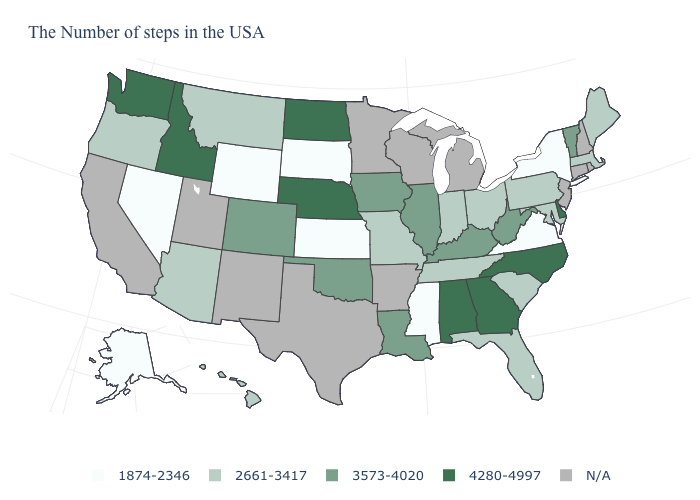What is the value of Nebraska?
Quick response, please. 4280-4997. Which states hav the highest value in the West?
Give a very brief answer. Idaho, Washington. What is the value of Vermont?
Answer briefly. 3573-4020. Name the states that have a value in the range 4280-4997?
Give a very brief answer. Delaware, North Carolina, Georgia, Alabama, Nebraska, North Dakota, Idaho, Washington. Name the states that have a value in the range 4280-4997?
Keep it brief. Delaware, North Carolina, Georgia, Alabama, Nebraska, North Dakota, Idaho, Washington. What is the lowest value in states that border Missouri?
Answer briefly. 1874-2346. What is the lowest value in the South?
Write a very short answer. 1874-2346. Does the map have missing data?
Be succinct. Yes. What is the value of Alabama?
Write a very short answer. 4280-4997. Name the states that have a value in the range 1874-2346?
Write a very short answer. New York, Virginia, Mississippi, Kansas, South Dakota, Wyoming, Nevada, Alaska. What is the lowest value in states that border Wyoming?
Write a very short answer. 1874-2346. What is the lowest value in states that border Washington?
Answer briefly. 2661-3417. Among the states that border Iowa , which have the highest value?
Short answer required. Nebraska. Which states have the lowest value in the MidWest?
Be succinct. Kansas, South Dakota. 